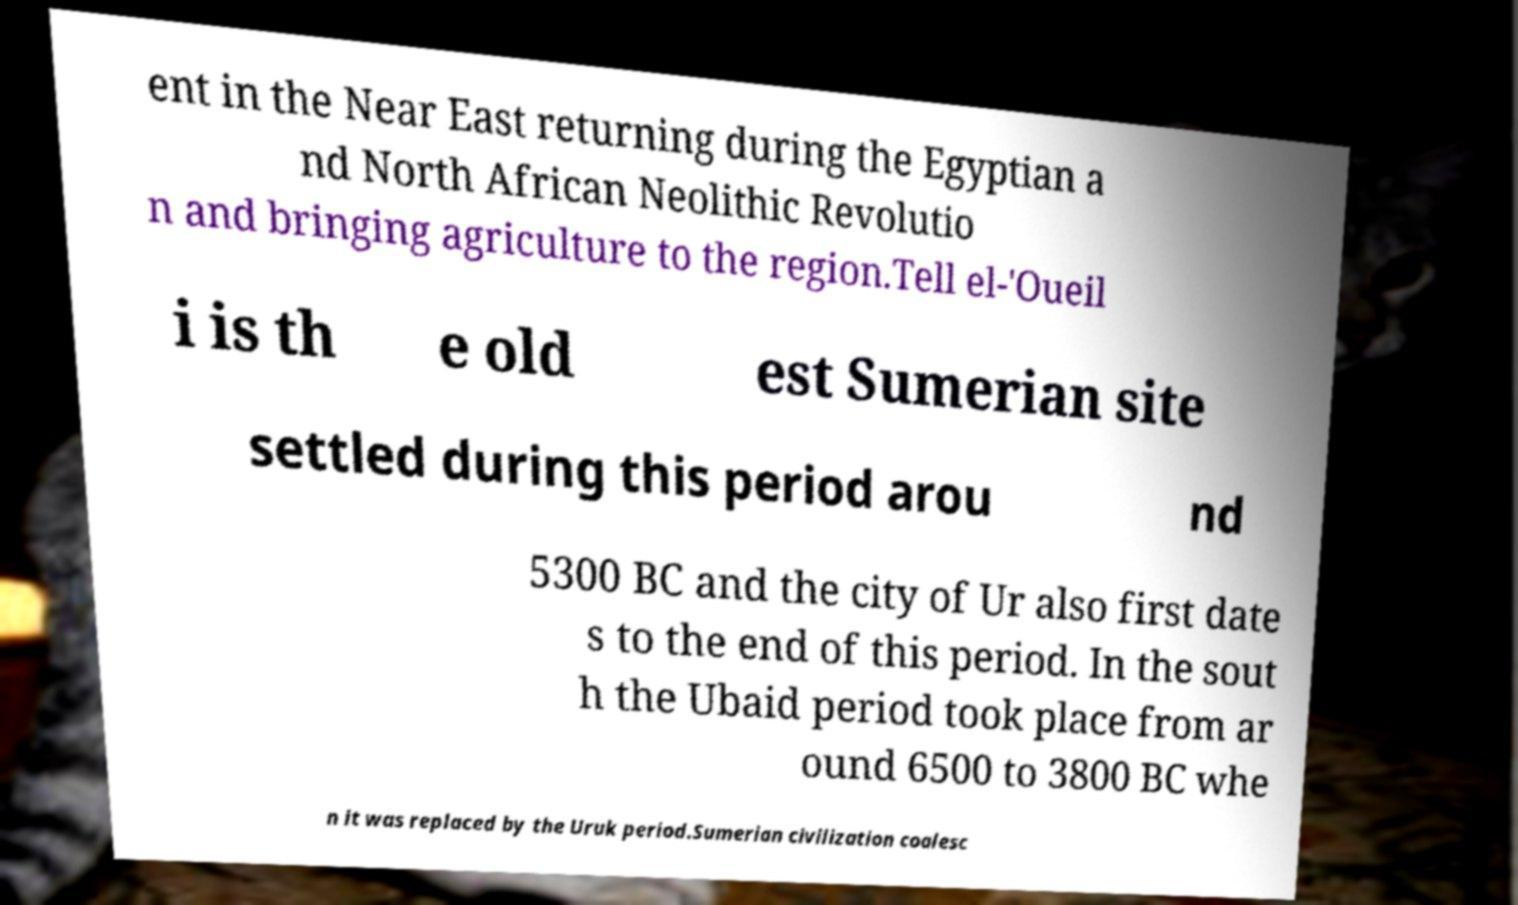There's text embedded in this image that I need extracted. Can you transcribe it verbatim? ent in the Near East returning during the Egyptian a nd North African Neolithic Revolutio n and bringing agriculture to the region.Tell el-'Oueil i is th e old est Sumerian site settled during this period arou nd 5300 BC and the city of Ur also first date s to the end of this period. In the sout h the Ubaid period took place from ar ound 6500 to 3800 BC whe n it was replaced by the Uruk period.Sumerian civilization coalesc 